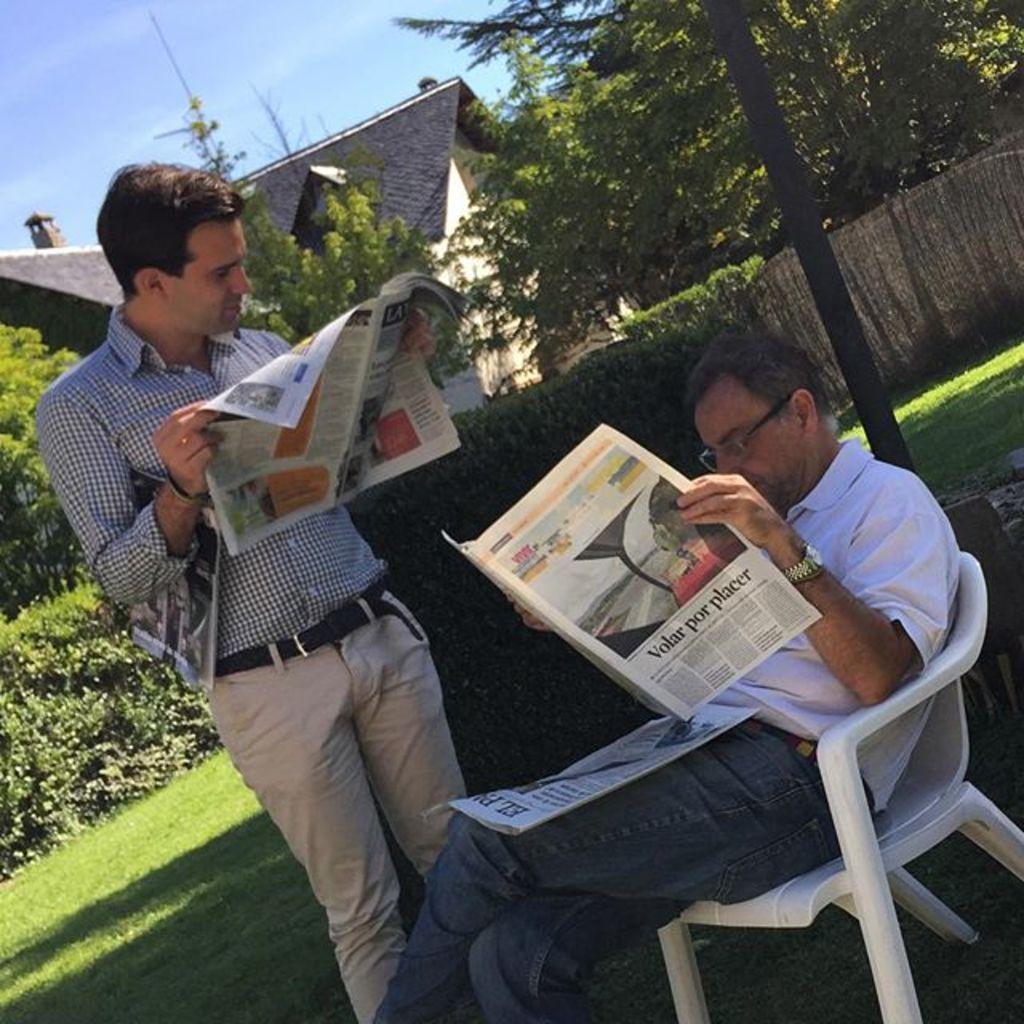Please provide a concise description of this image. A man is standing in a chair and reading newspaper. Another man beside him standing and reading. There are some trees and house in the background. 